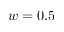<formula> <loc_0><loc_0><loc_500><loc_500>w = 0 . 5</formula> 